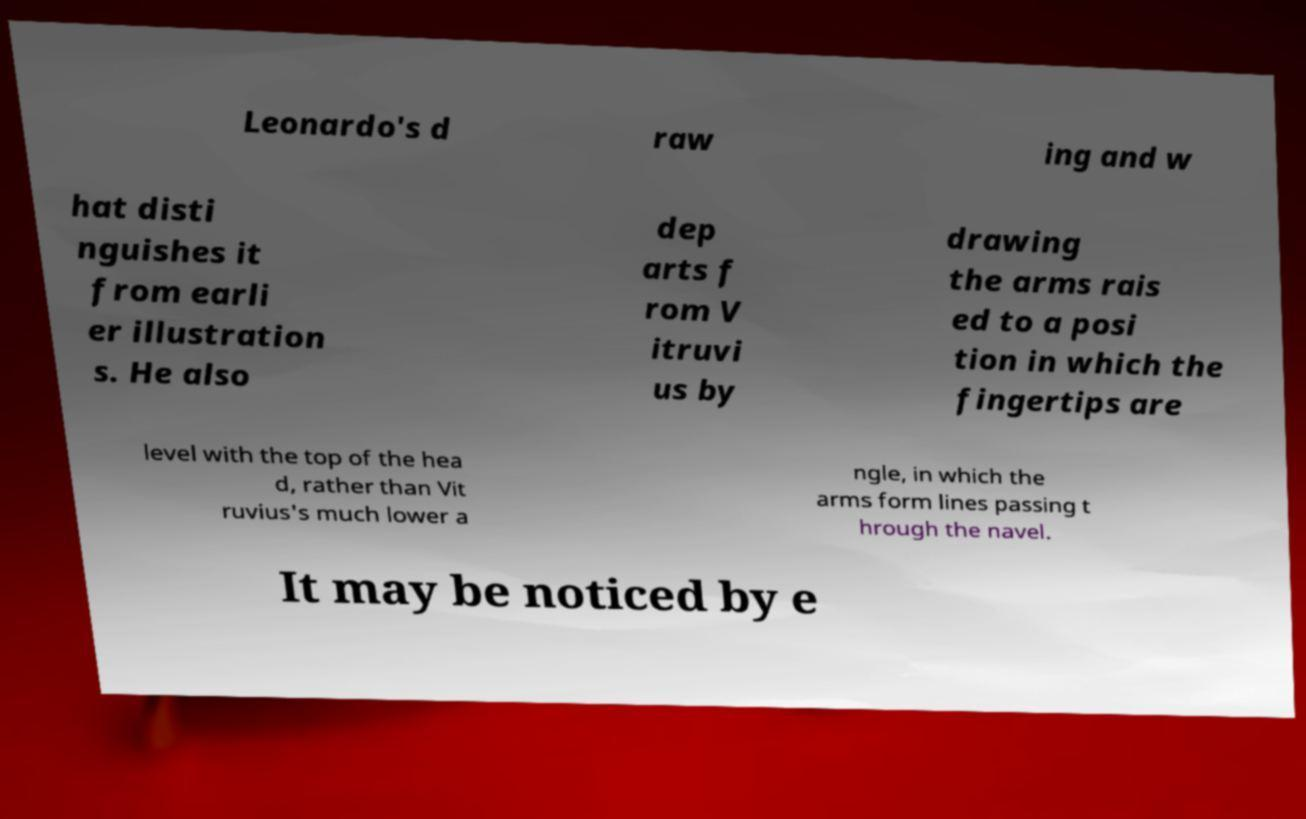Can you read and provide the text displayed in the image?This photo seems to have some interesting text. Can you extract and type it out for me? Leonardo's d raw ing and w hat disti nguishes it from earli er illustration s. He also dep arts f rom V itruvi us by drawing the arms rais ed to a posi tion in which the fingertips are level with the top of the hea d, rather than Vit ruvius's much lower a ngle, in which the arms form lines passing t hrough the navel. It may be noticed by e 